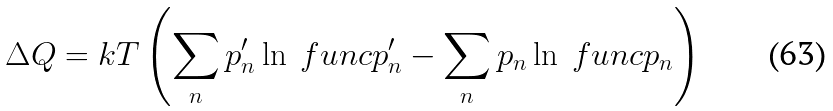Convert formula to latex. <formula><loc_0><loc_0><loc_500><loc_500>\Delta Q = k T \left ( \sum _ { n } p ^ { \prime } _ { n } \ln \ f u n c { p ^ { \prime } _ { n } } - \sum _ { n } p _ { n } \ln \ f u n c { p _ { n } } \right )</formula> 